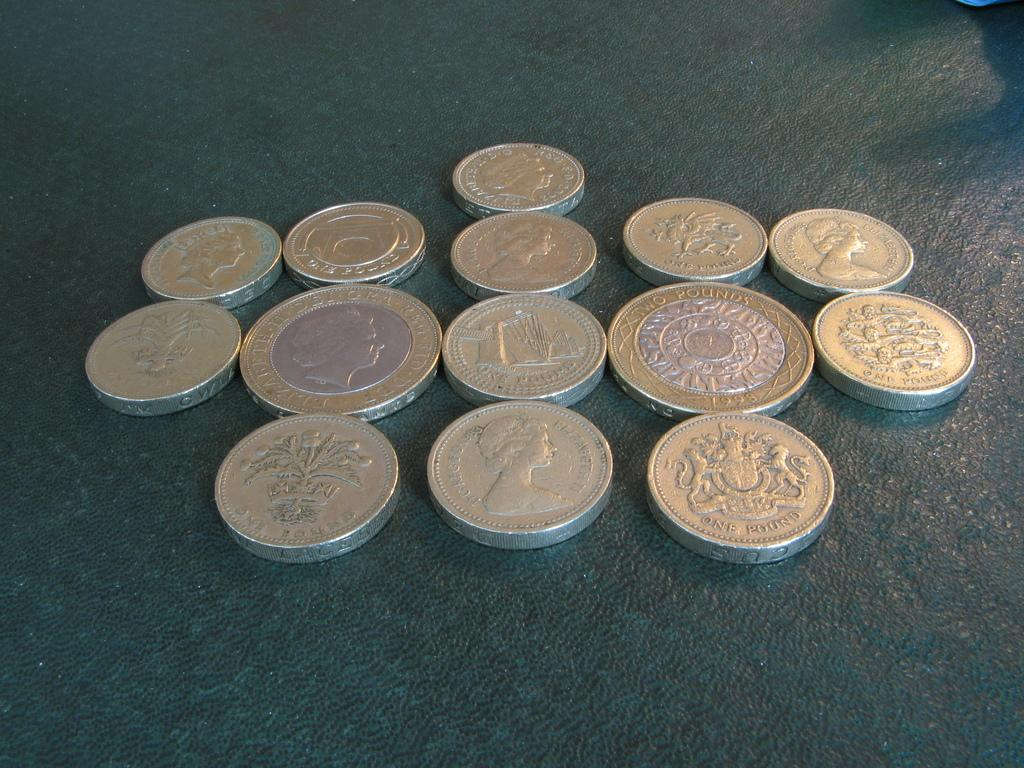<image>
Summarize the visual content of the image. The silver coins on the table have pounds on them 